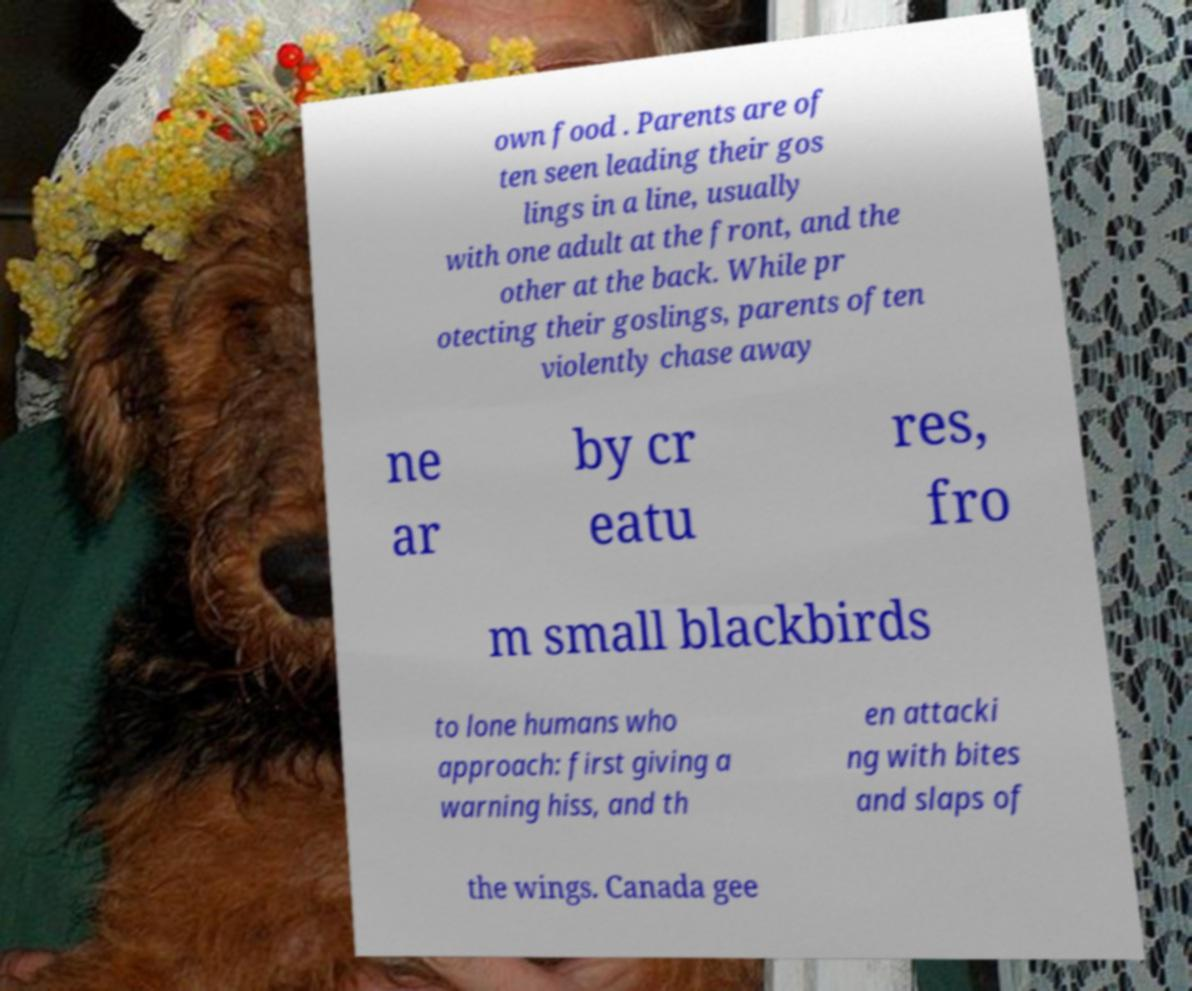Could you assist in decoding the text presented in this image and type it out clearly? own food . Parents are of ten seen leading their gos lings in a line, usually with one adult at the front, and the other at the back. While pr otecting their goslings, parents often violently chase away ne ar by cr eatu res, fro m small blackbirds to lone humans who approach: first giving a warning hiss, and th en attacki ng with bites and slaps of the wings. Canada gee 